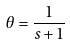Convert formula to latex. <formula><loc_0><loc_0><loc_500><loc_500>\theta = \frac { 1 } { s + 1 }</formula> 